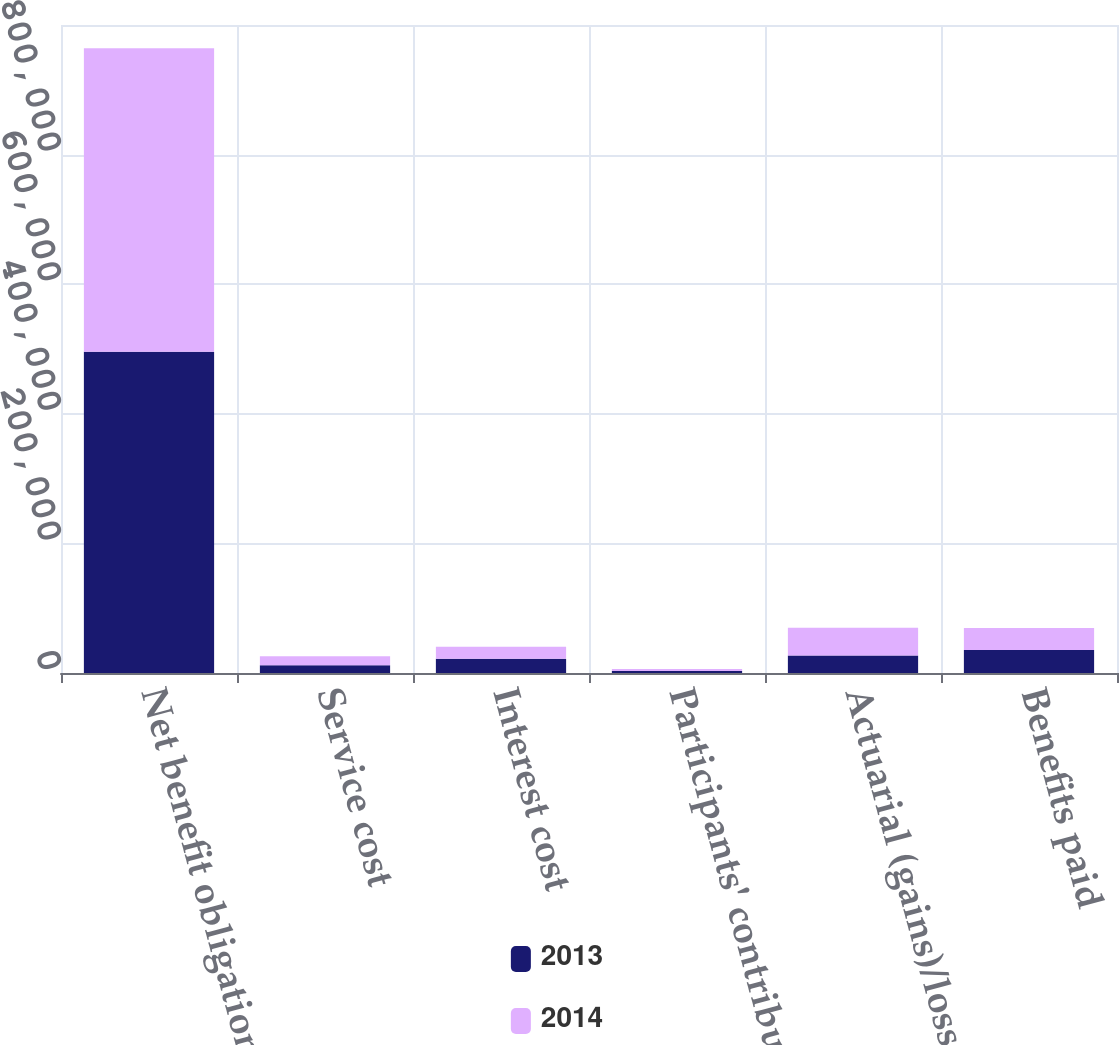Convert chart to OTSL. <chart><loc_0><loc_0><loc_500><loc_500><stacked_bar_chart><ecel><fcel>Net benefit obligation at the<fcel>Service cost<fcel>Interest cost<fcel>Participants' contributions<fcel>Actuarial (gains)/losses<fcel>Benefits paid<nl><fcel>2013<fcel>495788<fcel>12077<fcel>22041<fcel>3095<fcel>27076<fcel>35634<nl><fcel>2014<fcel>468439<fcel>13814<fcel>18569<fcel>3071<fcel>42689<fcel>33960<nl></chart> 